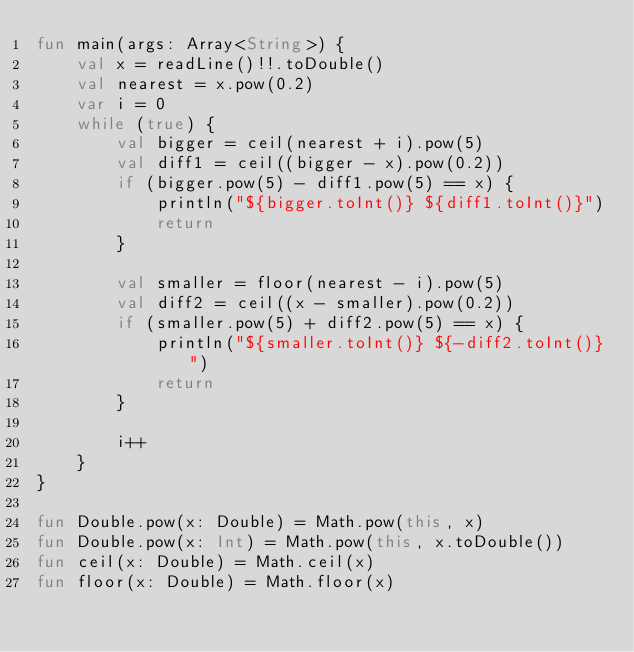<code> <loc_0><loc_0><loc_500><loc_500><_Kotlin_>fun main(args: Array<String>) {
    val x = readLine()!!.toDouble()
    val nearest = x.pow(0.2)
    var i = 0
    while (true) {
        val bigger = ceil(nearest + i).pow(5)
        val diff1 = ceil((bigger - x).pow(0.2))
        if (bigger.pow(5) - diff1.pow(5) == x) {
            println("${bigger.toInt()} ${diff1.toInt()}")
            return
        }

        val smaller = floor(nearest - i).pow(5)
        val diff2 = ceil((x - smaller).pow(0.2))
        if (smaller.pow(5) + diff2.pow(5) == x) {
            println("${smaller.toInt()} ${-diff2.toInt()}")
            return
        }

        i++
    }
}

fun Double.pow(x: Double) = Math.pow(this, x)
fun Double.pow(x: Int) = Math.pow(this, x.toDouble())
fun ceil(x: Double) = Math.ceil(x)
fun floor(x: Double) = Math.floor(x)</code> 